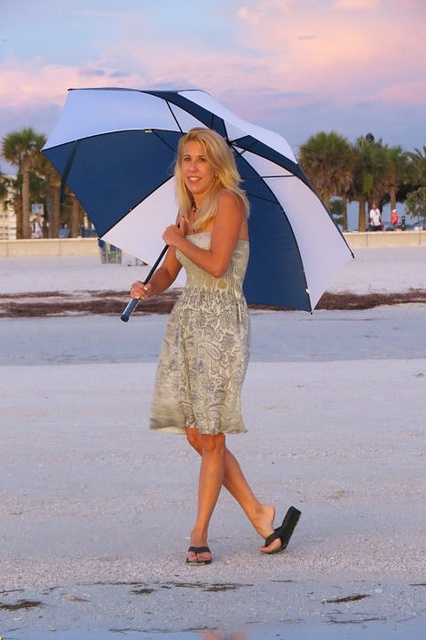Describe the objects in this image and their specific colors. I can see umbrella in darkgray, navy, and lavender tones, people in darkgray, gray, brown, and tan tones, people in darkgray, lavender, black, and brown tones, people in darkgray, gray, and pink tones, and people in darkgray, salmon, gray, and brown tones in this image. 